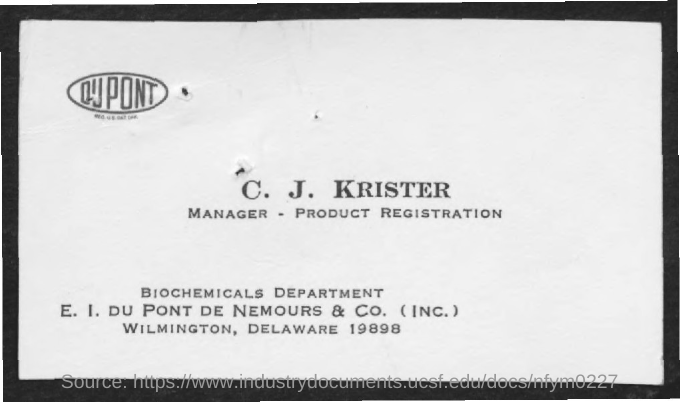List a handful of essential elements in this visual. C. J. KRISTER's designation is MANAGER and his area of expertise is PRODUCT REGISTRATION. The name of the department mentioned in the given form is: Biochemicals Department. 